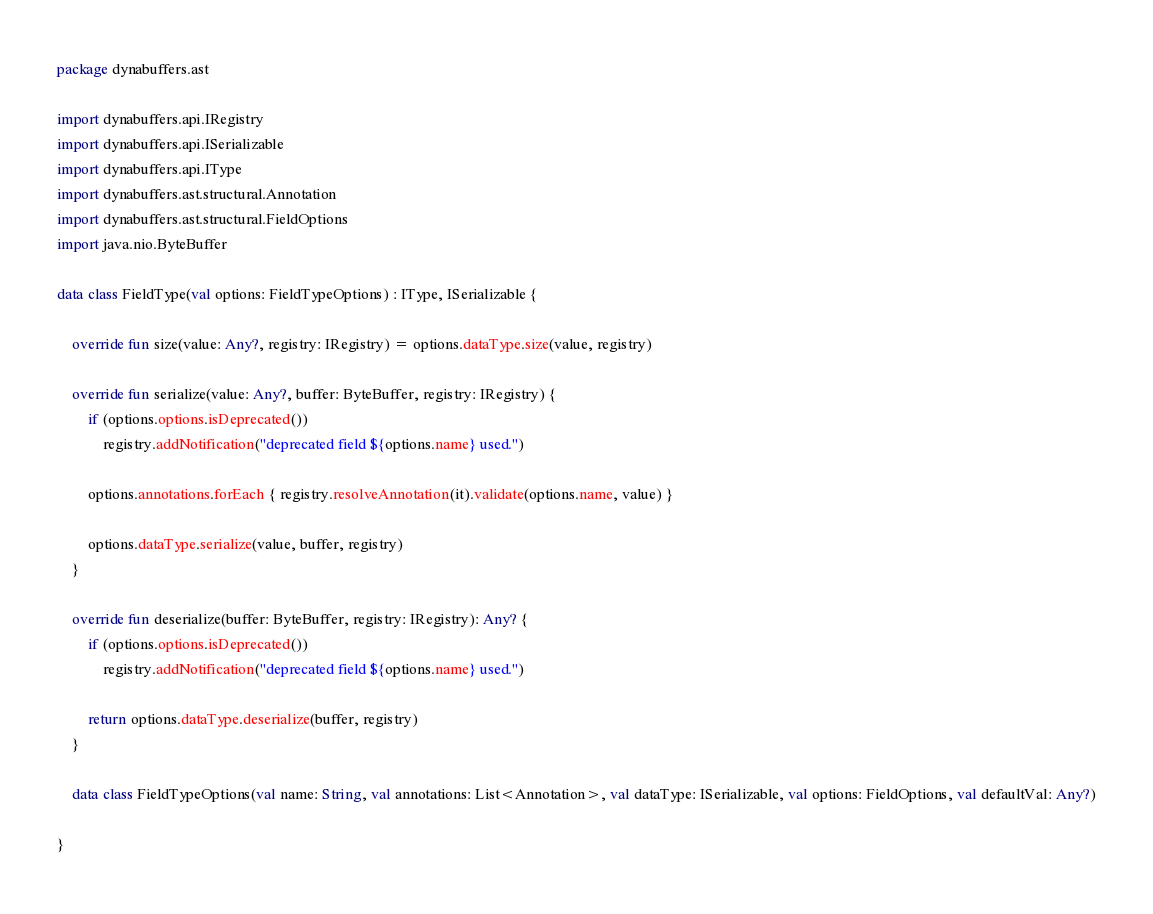<code> <loc_0><loc_0><loc_500><loc_500><_Kotlin_>package dynabuffers.ast

import dynabuffers.api.IRegistry
import dynabuffers.api.ISerializable
import dynabuffers.api.IType
import dynabuffers.ast.structural.Annotation
import dynabuffers.ast.structural.FieldOptions
import java.nio.ByteBuffer

data class FieldType(val options: FieldTypeOptions) : IType, ISerializable {

    override fun size(value: Any?, registry: IRegistry) = options.dataType.size(value, registry)

    override fun serialize(value: Any?, buffer: ByteBuffer, registry: IRegistry) {
        if (options.options.isDeprecated())
            registry.addNotification("deprecated field ${options.name} used.")

        options.annotations.forEach { registry.resolveAnnotation(it).validate(options.name, value) }

        options.dataType.serialize(value, buffer, registry)
    }

    override fun deserialize(buffer: ByteBuffer, registry: IRegistry): Any? {
        if (options.options.isDeprecated())
            registry.addNotification("deprecated field ${options.name} used.")

        return options.dataType.deserialize(buffer, registry)
    }

    data class FieldTypeOptions(val name: String, val annotations: List<Annotation>, val dataType: ISerializable, val options: FieldOptions, val defaultVal: Any?)

}
</code> 